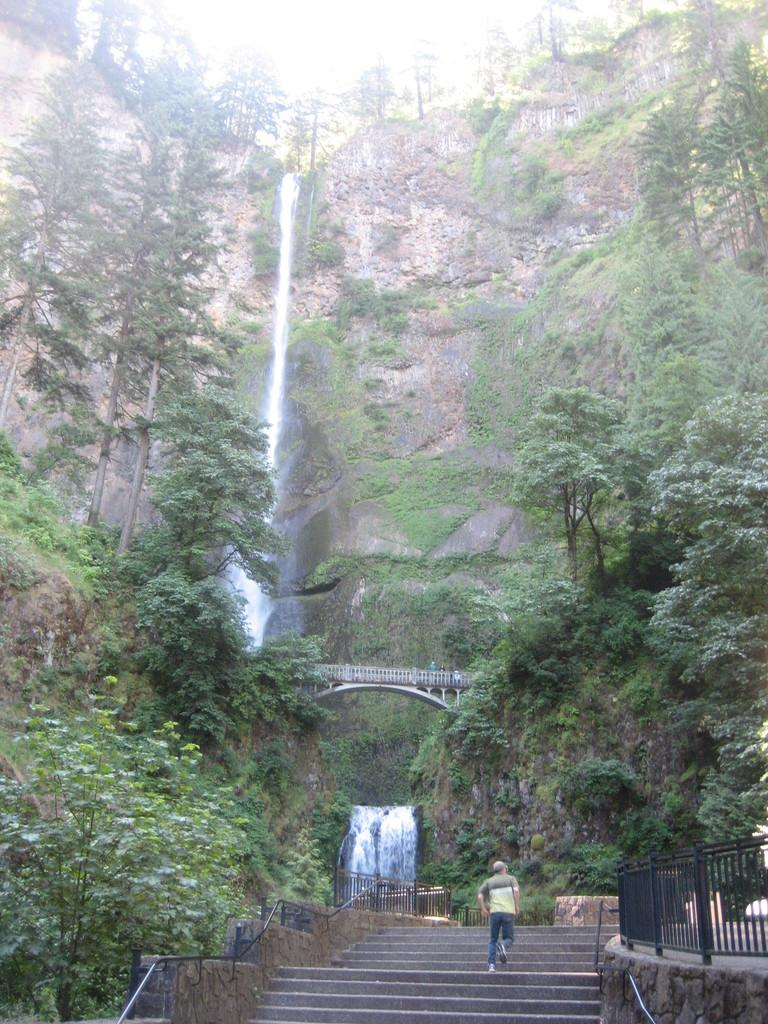What is the person in the image doing? The person is walking on steps in the image. Can you describe the steps in the image? The person is walking on steps, and there are trees on either side of the steps. What can be seen in the background of the image? There is a hill in the background of the image, and there is a waterfall in the middle of the hill. What type of lunch is the person eating while walking on the steps? There is no indication in the image that the person is eating lunch, so it cannot be determined from the picture. 